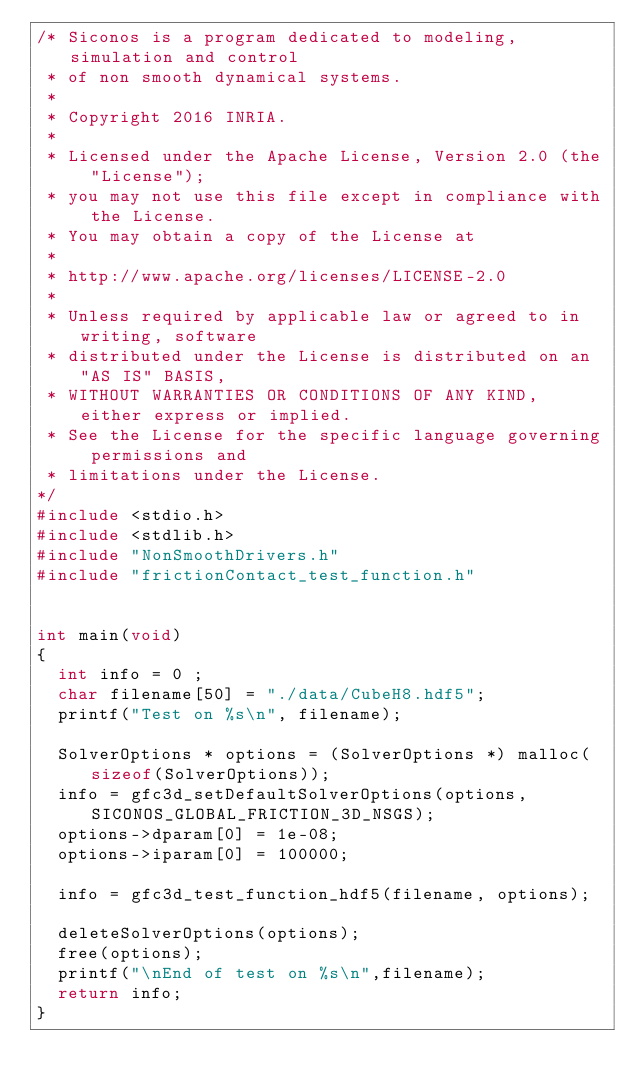Convert code to text. <code><loc_0><loc_0><loc_500><loc_500><_C_>/* Siconos is a program dedicated to modeling, simulation and control
 * of non smooth dynamical systems.
 *
 * Copyright 2016 INRIA.
 *
 * Licensed under the Apache License, Version 2.0 (the "License");
 * you may not use this file except in compliance with the License.
 * You may obtain a copy of the License at
 *
 * http://www.apache.org/licenses/LICENSE-2.0
 *
 * Unless required by applicable law or agreed to in writing, software
 * distributed under the License is distributed on an "AS IS" BASIS,
 * WITHOUT WARRANTIES OR CONDITIONS OF ANY KIND, either express or implied.
 * See the License for the specific language governing permissions and
 * limitations under the License.
*/
#include <stdio.h>
#include <stdlib.h>
#include "NonSmoothDrivers.h"
#include "frictionContact_test_function.h"


int main(void)
{
  int info = 0 ;
  char filename[50] = "./data/CubeH8.hdf5";
  printf("Test on %s\n", filename);

  SolverOptions * options = (SolverOptions *) malloc(sizeof(SolverOptions));
  info = gfc3d_setDefaultSolverOptions(options, SICONOS_GLOBAL_FRICTION_3D_NSGS);
  options->dparam[0] = 1e-08;
  options->iparam[0] = 100000;

  info = gfc3d_test_function_hdf5(filename, options);

  deleteSolverOptions(options);
  free(options);
  printf("\nEnd of test on %s\n",filename);
  return info;
}
</code> 